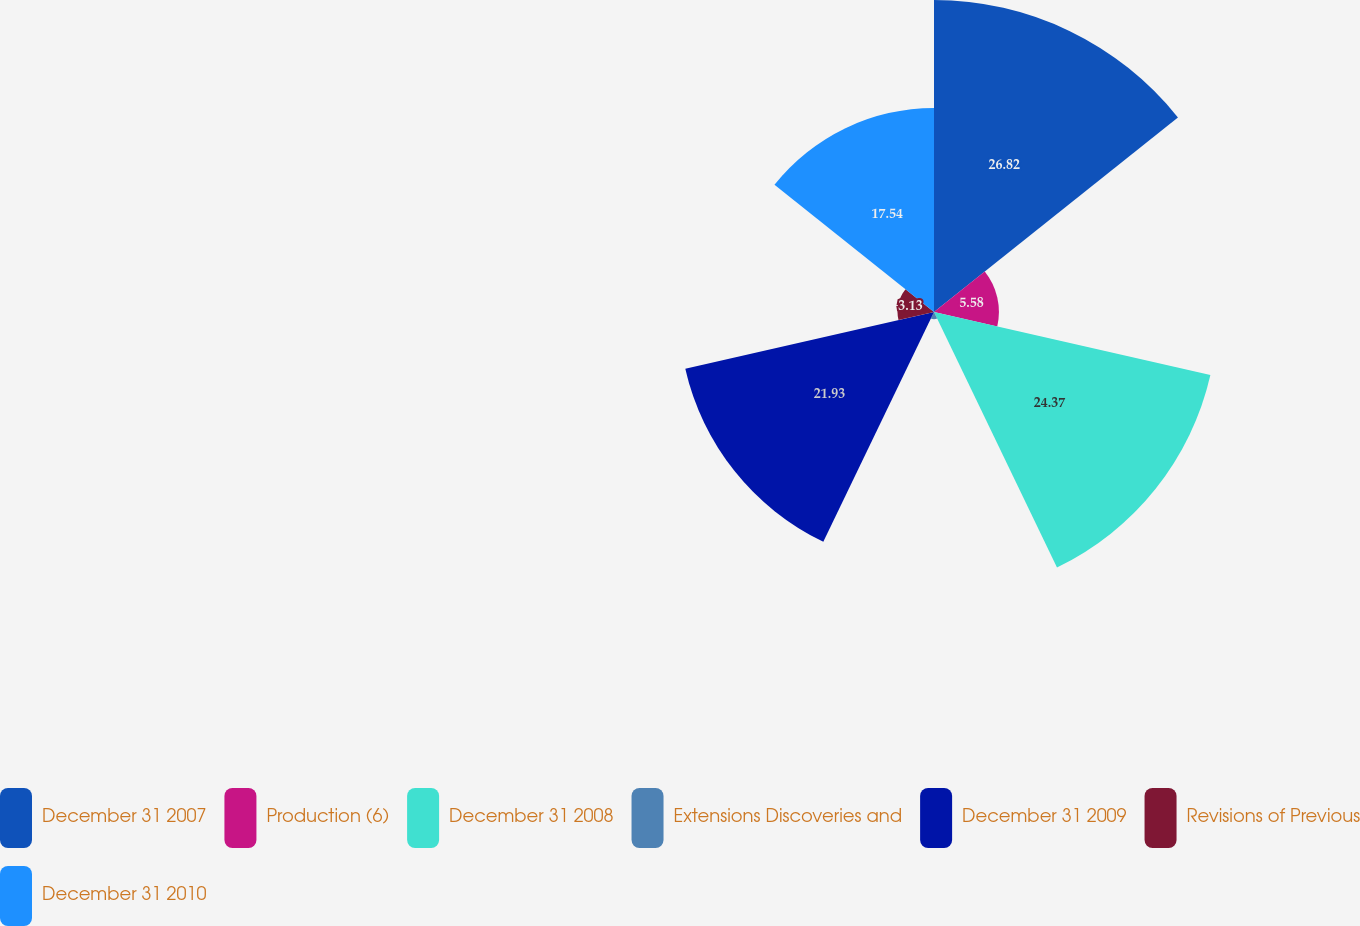<chart> <loc_0><loc_0><loc_500><loc_500><pie_chart><fcel>December 31 2007<fcel>Production (6)<fcel>December 31 2008<fcel>Extensions Discoveries and<fcel>December 31 2009<fcel>Revisions of Previous<fcel>December 31 2010<nl><fcel>26.82%<fcel>5.58%<fcel>24.37%<fcel>0.63%<fcel>21.93%<fcel>3.13%<fcel>17.54%<nl></chart> 